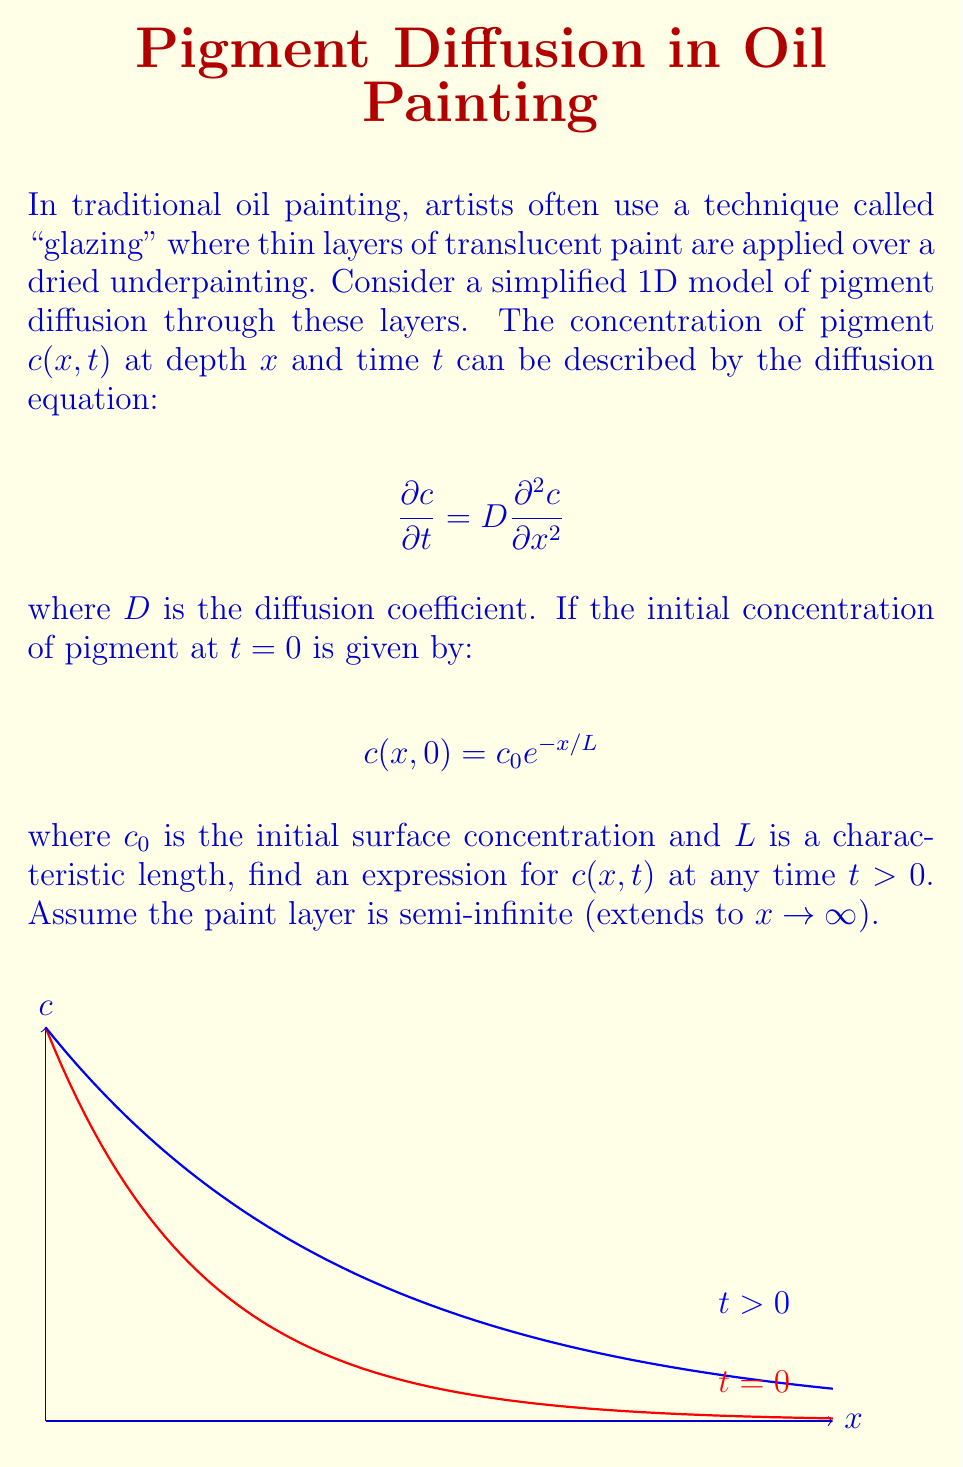Provide a solution to this math problem. To solve this problem, we'll follow these steps:

1) The diffusion equation with the given initial condition is a standard problem that can be solved using the method of similarity solution.

2) We introduce a similarity variable $\eta = \frac{x}{\sqrt{4Dt}}$.

3) We assume a solution of the form:
   $$c(x,t) = c_0 f(\eta) e^{-x/L}$$

4) Substituting this into the diffusion equation:

   $$\frac{\partial c}{\partial t} = c_0 e^{-x/L} \left(-\frac{\eta}{2t}f'(\eta)\right)$$
   
   $$\frac{\partial^2 c}{\partial x^2} = c_0 e^{-x/L} \left(\frac{f''(\eta)}{4Dt} + \frac{2f'(\eta)}{L\sqrt{4Dt}} + \frac{f(\eta)}{L^2}\right)$$

5) Equating these and simplifying:

   $$f''(\eta) + 2\eta f'(\eta) + 4DL\left(\frac{f'(\eta)}{L} + \frac{f(\eta)}{L^2}\right) = 0$$

6) This is a second-order ODE. The solution that satisfies the boundary conditions is:

   $$f(\eta) = \exp\left(\frac{Dt}{L^2} + \frac{\eta L}{\sqrt{Dt}}\right)$$

7) Substituting back the original variables:

   $$c(x,t) = c_0 \exp\left(\frac{Dt}{L^2} + \frac{xL}{\sqrt{4D^3t}} - \frac{x}{L}\right)$$

8) This can be simplified to:

   $$c(x,t) = c_0 \exp\left(\frac{Dt}{L^2} + \frac{x^2}{4Dt} - \frac{x}{L}\right)$$

This is the final solution for the concentration profile at any time $t > 0$.
Answer: $c(x,t) = c_0 \exp\left(\frac{Dt}{L^2} + \frac{x^2}{4Dt} - \frac{x}{L}\right)$ 